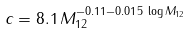Convert formula to latex. <formula><loc_0><loc_0><loc_500><loc_500>c = 8 . 1 \, M _ { 1 2 } ^ { - 0 . 1 1 - 0 . 0 1 5 \, \log M _ { 1 2 } } \,</formula> 